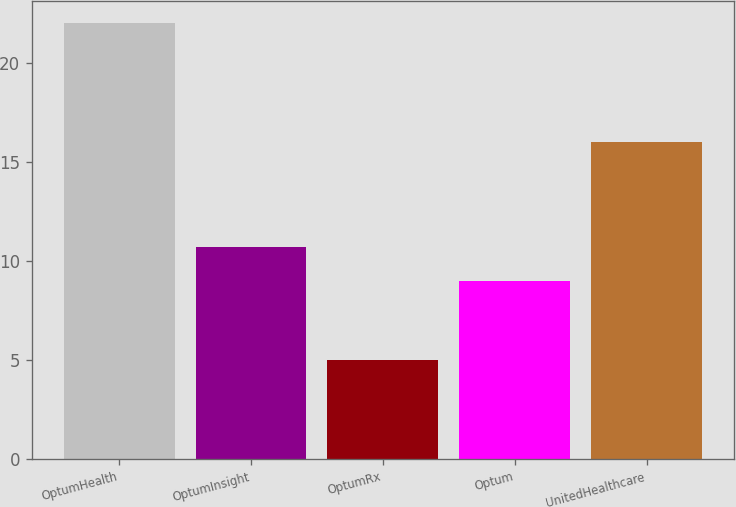Convert chart. <chart><loc_0><loc_0><loc_500><loc_500><bar_chart><fcel>OptumHealth<fcel>OptumInsight<fcel>OptumRx<fcel>Optum<fcel>UnitedHealthcare<nl><fcel>22<fcel>10.7<fcel>5<fcel>9<fcel>16<nl></chart> 